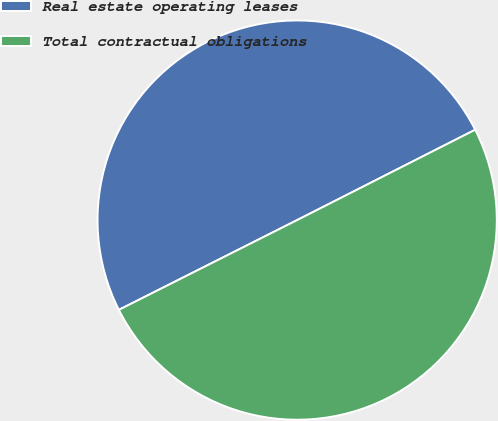Convert chart. <chart><loc_0><loc_0><loc_500><loc_500><pie_chart><fcel>Real estate operating leases<fcel>Total contractual obligations<nl><fcel>49.95%<fcel>50.05%<nl></chart> 